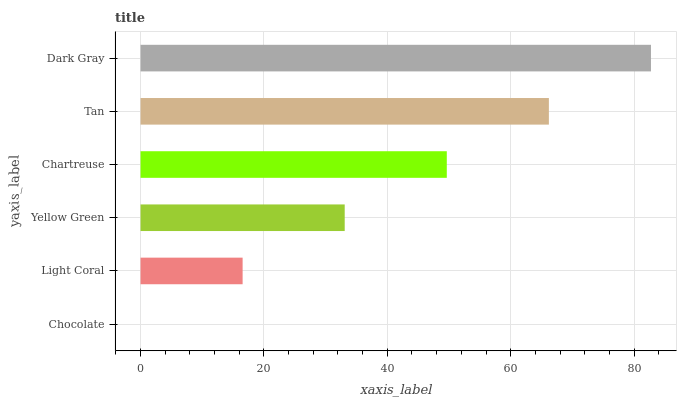Is Chocolate the minimum?
Answer yes or no. Yes. Is Dark Gray the maximum?
Answer yes or no. Yes. Is Light Coral the minimum?
Answer yes or no. No. Is Light Coral the maximum?
Answer yes or no. No. Is Light Coral greater than Chocolate?
Answer yes or no. Yes. Is Chocolate less than Light Coral?
Answer yes or no. Yes. Is Chocolate greater than Light Coral?
Answer yes or no. No. Is Light Coral less than Chocolate?
Answer yes or no. No. Is Chartreuse the high median?
Answer yes or no. Yes. Is Yellow Green the low median?
Answer yes or no. Yes. Is Chocolate the high median?
Answer yes or no. No. Is Light Coral the low median?
Answer yes or no. No. 